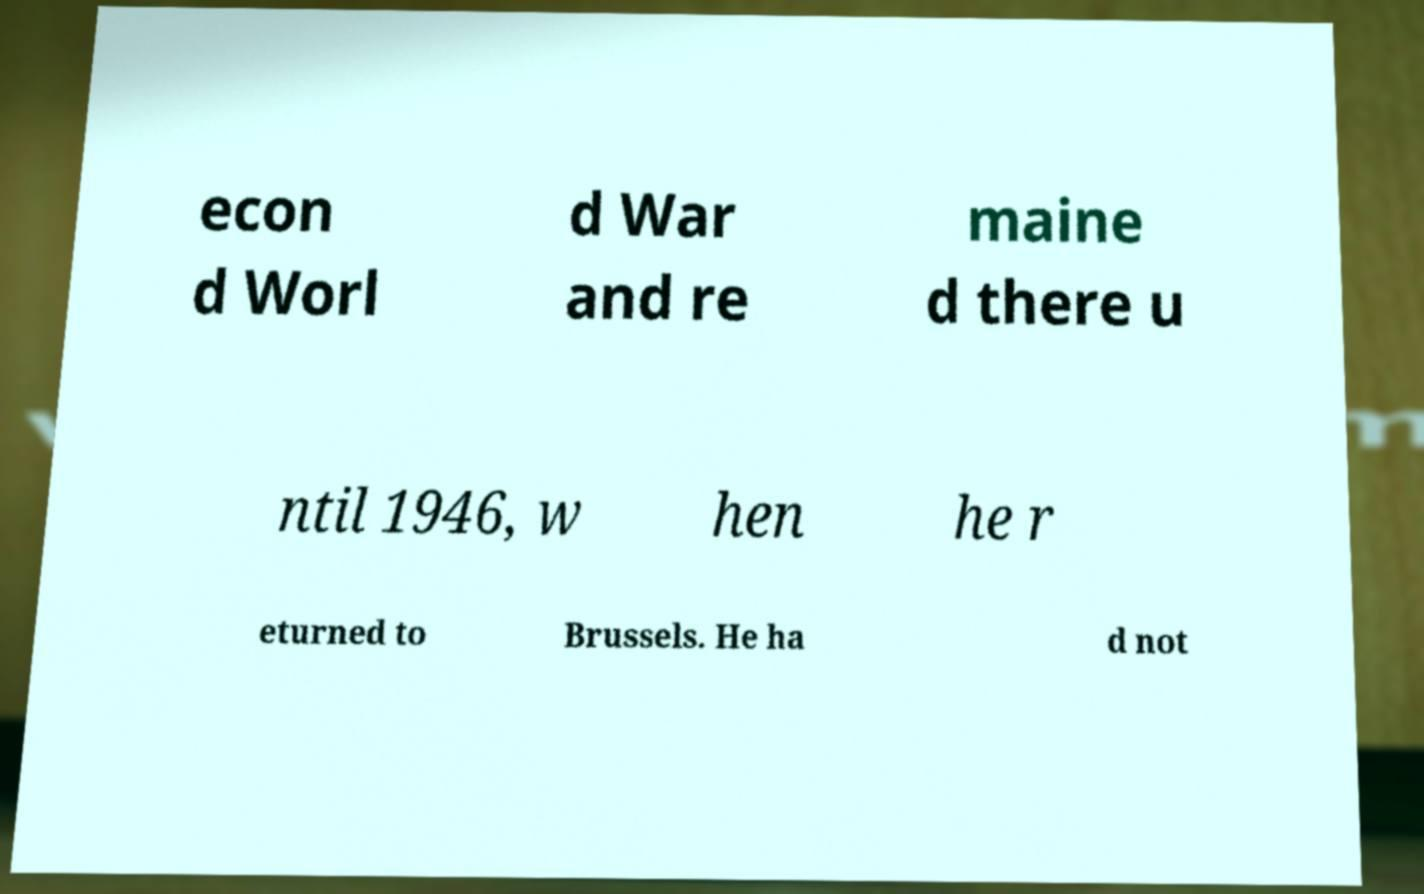What messages or text are displayed in this image? I need them in a readable, typed format. econ d Worl d War and re maine d there u ntil 1946, w hen he r eturned to Brussels. He ha d not 